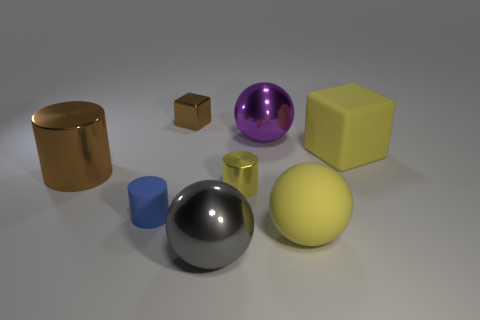Are there any big purple balls made of the same material as the gray ball?
Your answer should be very brief. Yes. What size is the rubber sphere that is the same color as the small metal cylinder?
Your answer should be compact. Large. How many cylinders are either cyan rubber things or large brown objects?
Keep it short and to the point. 1. Is the number of big purple metal things that are behind the big gray thing greater than the number of large cylinders in front of the yellow cylinder?
Offer a very short reply. Yes. What number of big metal balls are the same color as the large block?
Provide a short and direct response. 0. There is another ball that is made of the same material as the gray sphere; what size is it?
Your answer should be very brief. Large. What number of things are big things that are in front of the large rubber cube or tiny brown metal blocks?
Offer a terse response. 4. There is a small shiny object that is in front of the purple ball; is it the same color as the matte cube?
Offer a terse response. Yes. What is the size of the other thing that is the same shape as the small brown thing?
Your answer should be compact. Large. There is a large metallic object that is behind the matte object that is behind the small cylinder to the right of the small brown thing; what color is it?
Provide a short and direct response. Purple. 